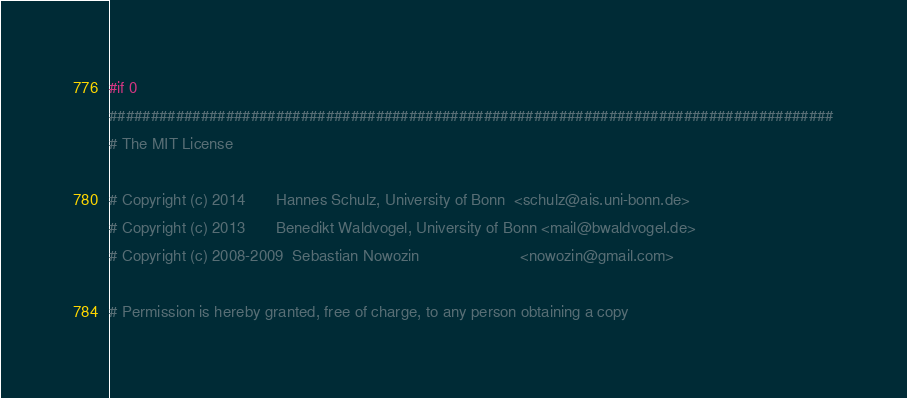Convert code to text. <code><loc_0><loc_0><loc_500><loc_500><_Cuda_>#if 0
#######################################################################################
# The MIT License

# Copyright (c) 2014       Hannes Schulz, University of Bonn  <schulz@ais.uni-bonn.de>
# Copyright (c) 2013       Benedikt Waldvogel, University of Bonn <mail@bwaldvogel.de>
# Copyright (c) 2008-2009  Sebastian Nowozin                       <nowozin@gmail.com>

# Permission is hereby granted, free of charge, to any person obtaining a copy</code> 